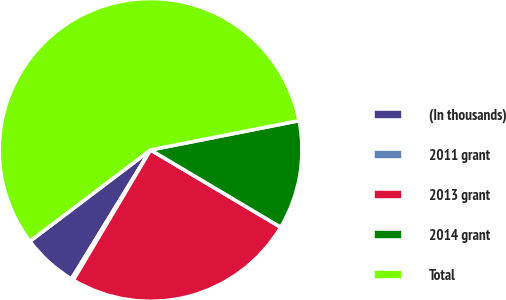Convert chart to OTSL. <chart><loc_0><loc_0><loc_500><loc_500><pie_chart><fcel>(In thousands)<fcel>2011 grant<fcel>2013 grant<fcel>2014 grant<fcel>Total<nl><fcel>5.93%<fcel>0.23%<fcel>25.0%<fcel>11.63%<fcel>57.22%<nl></chart> 